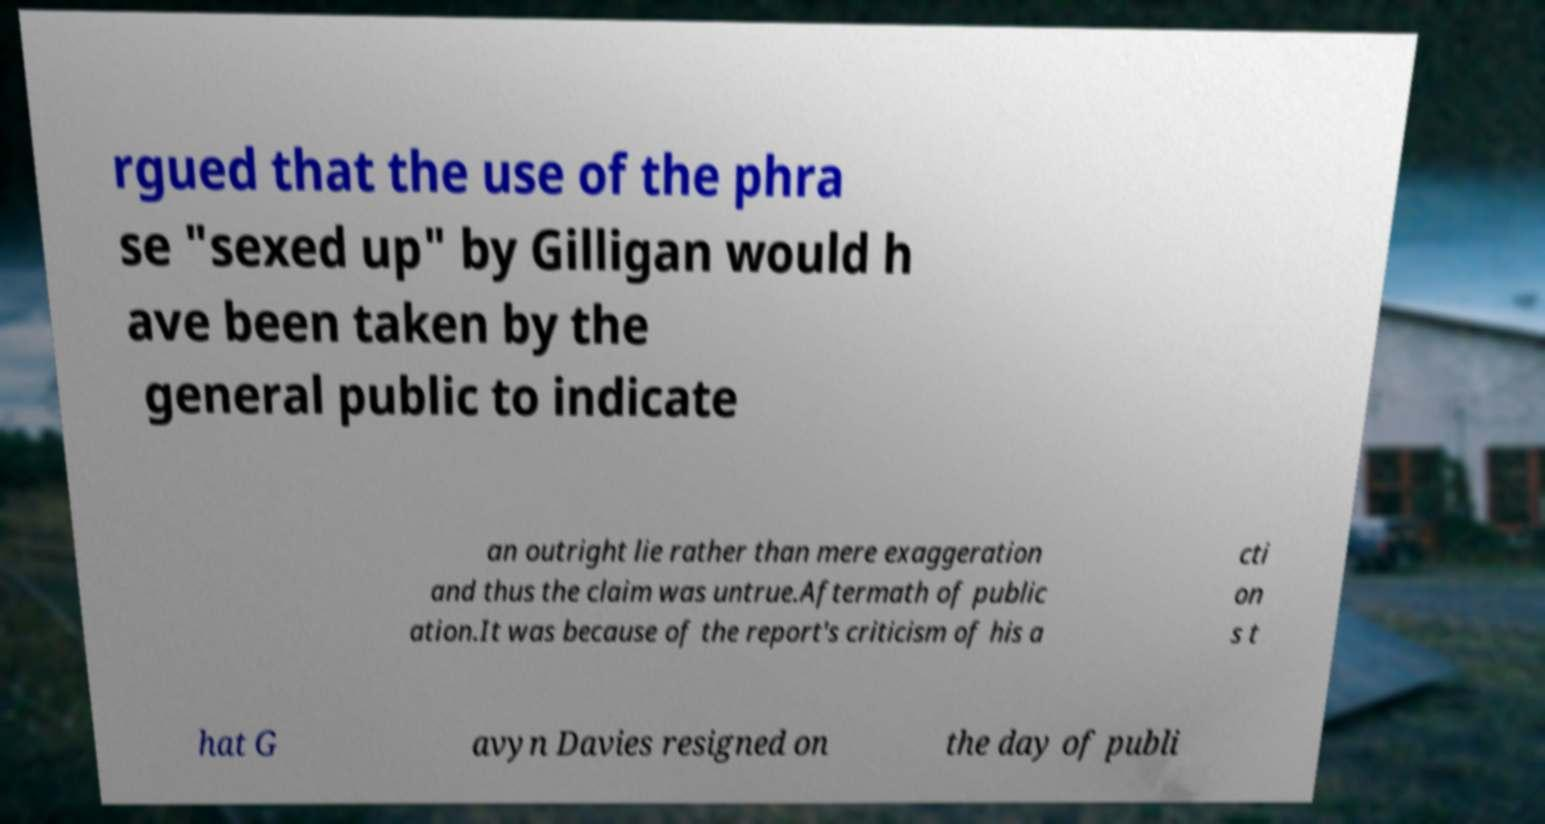Could you extract and type out the text from this image? rgued that the use of the phra se "sexed up" by Gilligan would h ave been taken by the general public to indicate an outright lie rather than mere exaggeration and thus the claim was untrue.Aftermath of public ation.It was because of the report's criticism of his a cti on s t hat G avyn Davies resigned on the day of publi 